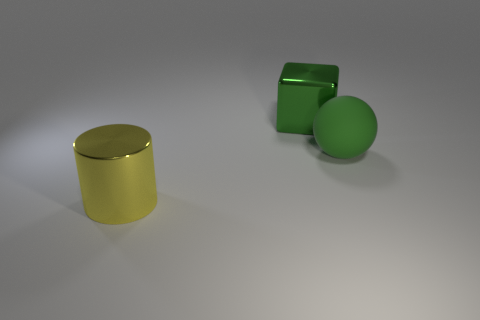Add 1 cyan things. How many objects exist? 4 Subtract all balls. How many objects are left? 2 Subtract 0 brown balls. How many objects are left? 3 Subtract all brown matte blocks. Subtract all cylinders. How many objects are left? 2 Add 2 large green metallic things. How many large green metallic things are left? 3 Add 2 yellow things. How many yellow things exist? 3 